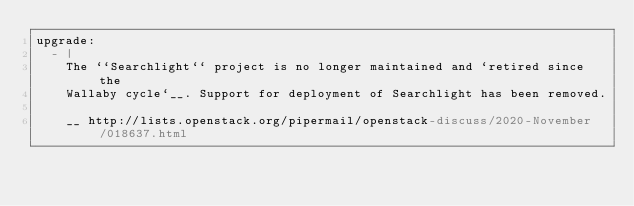<code> <loc_0><loc_0><loc_500><loc_500><_YAML_>upgrade:
  - |
    The ``Searchlight`` project is no longer maintained and `retired since the
    Wallaby cycle`__. Support for deployment of Searchlight has been removed.

    __ http://lists.openstack.org/pipermail/openstack-discuss/2020-November/018637.html
</code> 